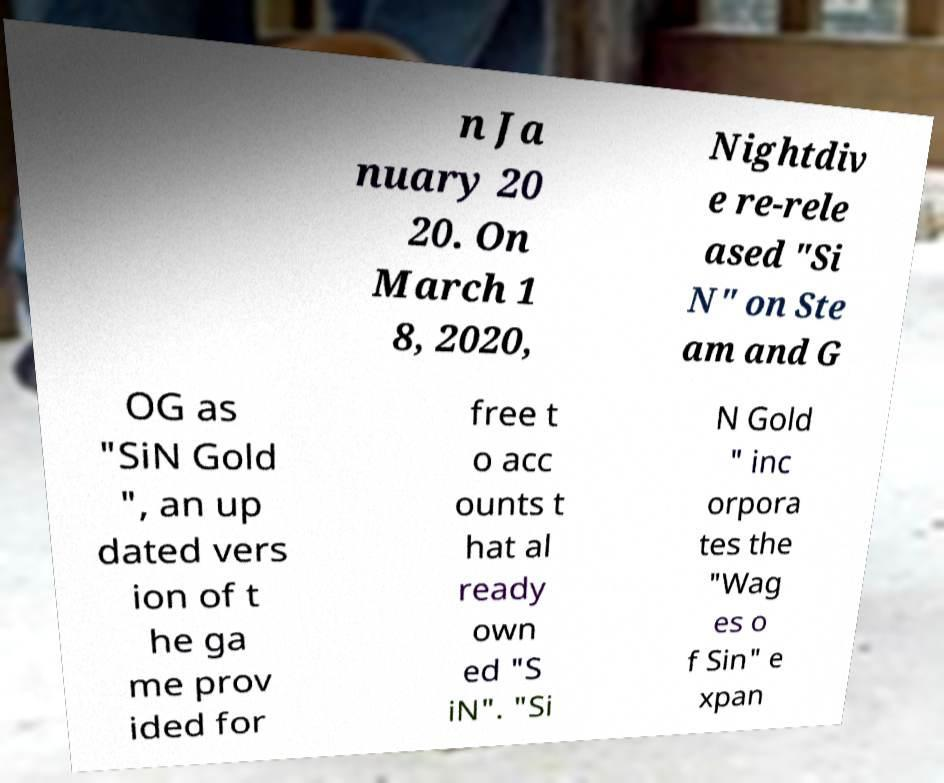Please read and relay the text visible in this image. What does it say? n Ja nuary 20 20. On March 1 8, 2020, Nightdiv e re-rele ased "Si N" on Ste am and G OG as "SiN Gold ", an up dated vers ion of t he ga me prov ided for free t o acc ounts t hat al ready own ed "S iN". "Si N Gold " inc orpora tes the "Wag es o f Sin" e xpan 